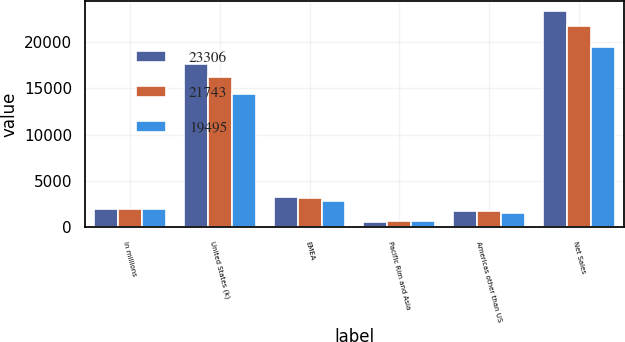<chart> <loc_0><loc_0><loc_500><loc_500><stacked_bar_chart><ecel><fcel>In millions<fcel>United States (k)<fcel>EMEA<fcel>Pacific Rim and Asia<fcel>Americas other than US<fcel>Net Sales<nl><fcel>23306<fcel>2018<fcel>17609<fcel>3321<fcel>605<fcel>1771<fcel>23306<nl><fcel>21743<fcel>2017<fcel>16247<fcel>3129<fcel>625<fcel>1742<fcel>21743<nl><fcel>19495<fcel>2016<fcel>14363<fcel>2852<fcel>699<fcel>1581<fcel>19495<nl></chart> 